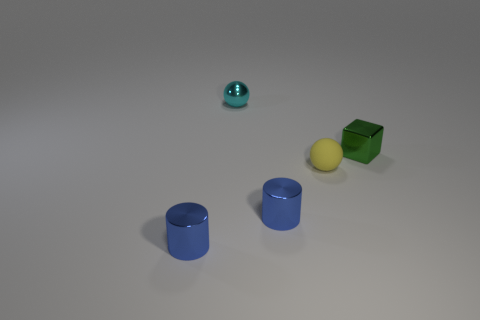Add 1 blocks. How many objects exist? 6 Subtract 1 cubes. How many cubes are left? 0 Add 4 large yellow shiny blocks. How many large yellow shiny blocks exist? 4 Subtract all cyan balls. How many balls are left? 1 Subtract 0 brown cubes. How many objects are left? 5 Subtract all cubes. How many objects are left? 4 Subtract all cyan blocks. Subtract all red balls. How many blocks are left? 1 Subtract all yellow blocks. How many brown cylinders are left? 0 Subtract all blue shiny cylinders. Subtract all shiny blocks. How many objects are left? 2 Add 2 small things. How many small things are left? 7 